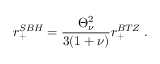Convert formula to latex. <formula><loc_0><loc_0><loc_500><loc_500>r _ { + } ^ { S B H } = \frac { \Theta _ { \nu } ^ { 2 } } { 3 ( 1 + \nu ) } r _ { + } ^ { B T Z } \, .</formula> 